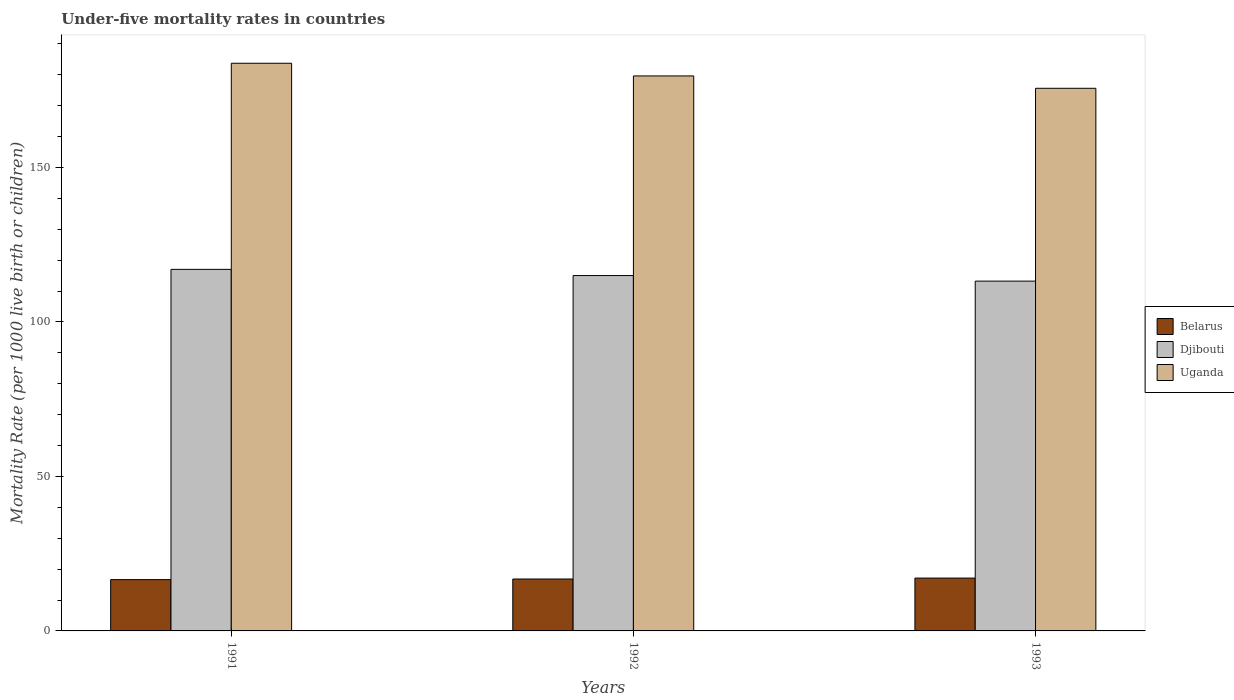How many different coloured bars are there?
Ensure brevity in your answer.  3. How many groups of bars are there?
Offer a terse response. 3. Are the number of bars per tick equal to the number of legend labels?
Your answer should be very brief. Yes. Are the number of bars on each tick of the X-axis equal?
Make the answer very short. Yes. How many bars are there on the 3rd tick from the right?
Your answer should be compact. 3. What is the label of the 2nd group of bars from the left?
Make the answer very short. 1992. In how many cases, is the number of bars for a given year not equal to the number of legend labels?
Keep it short and to the point. 0. What is the under-five mortality rate in Uganda in 1993?
Your answer should be compact. 175.6. Across all years, what is the maximum under-five mortality rate in Uganda?
Offer a terse response. 183.7. Across all years, what is the minimum under-five mortality rate in Djibouti?
Keep it short and to the point. 113.2. In which year was the under-five mortality rate in Djibouti minimum?
Offer a terse response. 1993. What is the total under-five mortality rate in Uganda in the graph?
Keep it short and to the point. 538.9. What is the difference between the under-five mortality rate in Belarus in 1991 and that in 1992?
Provide a short and direct response. -0.2. What is the difference between the under-five mortality rate in Belarus in 1992 and the under-five mortality rate in Djibouti in 1993?
Keep it short and to the point. -96.4. What is the average under-five mortality rate in Belarus per year?
Offer a very short reply. 16.83. In the year 1993, what is the difference between the under-five mortality rate in Belarus and under-five mortality rate in Uganda?
Your response must be concise. -158.5. In how many years, is the under-five mortality rate in Belarus greater than 70?
Offer a terse response. 0. What is the ratio of the under-five mortality rate in Djibouti in 1991 to that in 1993?
Offer a very short reply. 1.03. Is the difference between the under-five mortality rate in Belarus in 1991 and 1992 greater than the difference between the under-five mortality rate in Uganda in 1991 and 1992?
Keep it short and to the point. No. What is the difference between the highest and the second highest under-five mortality rate in Uganda?
Your answer should be compact. 4.1. What is the difference between the highest and the lowest under-five mortality rate in Belarus?
Your answer should be compact. 0.5. In how many years, is the under-five mortality rate in Belarus greater than the average under-five mortality rate in Belarus taken over all years?
Your response must be concise. 1. What does the 2nd bar from the left in 1991 represents?
Offer a terse response. Djibouti. What does the 1st bar from the right in 1991 represents?
Give a very brief answer. Uganda. How many bars are there?
Your answer should be very brief. 9. Are all the bars in the graph horizontal?
Offer a terse response. No. What is the difference between two consecutive major ticks on the Y-axis?
Provide a short and direct response. 50. How many legend labels are there?
Keep it short and to the point. 3. How are the legend labels stacked?
Your response must be concise. Vertical. What is the title of the graph?
Keep it short and to the point. Under-five mortality rates in countries. Does "Lithuania" appear as one of the legend labels in the graph?
Offer a very short reply. No. What is the label or title of the Y-axis?
Give a very brief answer. Mortality Rate (per 1000 live birth or children). What is the Mortality Rate (per 1000 live birth or children) in Djibouti in 1991?
Your answer should be very brief. 117. What is the Mortality Rate (per 1000 live birth or children) in Uganda in 1991?
Give a very brief answer. 183.7. What is the Mortality Rate (per 1000 live birth or children) of Belarus in 1992?
Your response must be concise. 16.8. What is the Mortality Rate (per 1000 live birth or children) in Djibouti in 1992?
Offer a terse response. 115. What is the Mortality Rate (per 1000 live birth or children) of Uganda in 1992?
Your response must be concise. 179.6. What is the Mortality Rate (per 1000 live birth or children) of Djibouti in 1993?
Provide a succinct answer. 113.2. What is the Mortality Rate (per 1000 live birth or children) of Uganda in 1993?
Provide a succinct answer. 175.6. Across all years, what is the maximum Mortality Rate (per 1000 live birth or children) in Belarus?
Ensure brevity in your answer.  17.1. Across all years, what is the maximum Mortality Rate (per 1000 live birth or children) in Djibouti?
Offer a very short reply. 117. Across all years, what is the maximum Mortality Rate (per 1000 live birth or children) of Uganda?
Your answer should be compact. 183.7. Across all years, what is the minimum Mortality Rate (per 1000 live birth or children) in Belarus?
Your answer should be compact. 16.6. Across all years, what is the minimum Mortality Rate (per 1000 live birth or children) in Djibouti?
Your answer should be compact. 113.2. Across all years, what is the minimum Mortality Rate (per 1000 live birth or children) of Uganda?
Give a very brief answer. 175.6. What is the total Mortality Rate (per 1000 live birth or children) of Belarus in the graph?
Give a very brief answer. 50.5. What is the total Mortality Rate (per 1000 live birth or children) in Djibouti in the graph?
Offer a very short reply. 345.2. What is the total Mortality Rate (per 1000 live birth or children) in Uganda in the graph?
Keep it short and to the point. 538.9. What is the difference between the Mortality Rate (per 1000 live birth or children) of Belarus in 1991 and that in 1992?
Give a very brief answer. -0.2. What is the difference between the Mortality Rate (per 1000 live birth or children) of Djibouti in 1991 and that in 1993?
Provide a succinct answer. 3.8. What is the difference between the Mortality Rate (per 1000 live birth or children) of Uganda in 1992 and that in 1993?
Make the answer very short. 4. What is the difference between the Mortality Rate (per 1000 live birth or children) in Belarus in 1991 and the Mortality Rate (per 1000 live birth or children) in Djibouti in 1992?
Offer a very short reply. -98.4. What is the difference between the Mortality Rate (per 1000 live birth or children) of Belarus in 1991 and the Mortality Rate (per 1000 live birth or children) of Uganda in 1992?
Offer a very short reply. -163. What is the difference between the Mortality Rate (per 1000 live birth or children) of Djibouti in 1991 and the Mortality Rate (per 1000 live birth or children) of Uganda in 1992?
Make the answer very short. -62.6. What is the difference between the Mortality Rate (per 1000 live birth or children) in Belarus in 1991 and the Mortality Rate (per 1000 live birth or children) in Djibouti in 1993?
Give a very brief answer. -96.6. What is the difference between the Mortality Rate (per 1000 live birth or children) of Belarus in 1991 and the Mortality Rate (per 1000 live birth or children) of Uganda in 1993?
Ensure brevity in your answer.  -159. What is the difference between the Mortality Rate (per 1000 live birth or children) of Djibouti in 1991 and the Mortality Rate (per 1000 live birth or children) of Uganda in 1993?
Provide a succinct answer. -58.6. What is the difference between the Mortality Rate (per 1000 live birth or children) in Belarus in 1992 and the Mortality Rate (per 1000 live birth or children) in Djibouti in 1993?
Make the answer very short. -96.4. What is the difference between the Mortality Rate (per 1000 live birth or children) of Belarus in 1992 and the Mortality Rate (per 1000 live birth or children) of Uganda in 1993?
Provide a short and direct response. -158.8. What is the difference between the Mortality Rate (per 1000 live birth or children) in Djibouti in 1992 and the Mortality Rate (per 1000 live birth or children) in Uganda in 1993?
Make the answer very short. -60.6. What is the average Mortality Rate (per 1000 live birth or children) in Belarus per year?
Make the answer very short. 16.83. What is the average Mortality Rate (per 1000 live birth or children) in Djibouti per year?
Your response must be concise. 115.07. What is the average Mortality Rate (per 1000 live birth or children) in Uganda per year?
Offer a very short reply. 179.63. In the year 1991, what is the difference between the Mortality Rate (per 1000 live birth or children) of Belarus and Mortality Rate (per 1000 live birth or children) of Djibouti?
Offer a very short reply. -100.4. In the year 1991, what is the difference between the Mortality Rate (per 1000 live birth or children) in Belarus and Mortality Rate (per 1000 live birth or children) in Uganda?
Offer a very short reply. -167.1. In the year 1991, what is the difference between the Mortality Rate (per 1000 live birth or children) of Djibouti and Mortality Rate (per 1000 live birth or children) of Uganda?
Keep it short and to the point. -66.7. In the year 1992, what is the difference between the Mortality Rate (per 1000 live birth or children) in Belarus and Mortality Rate (per 1000 live birth or children) in Djibouti?
Provide a short and direct response. -98.2. In the year 1992, what is the difference between the Mortality Rate (per 1000 live birth or children) in Belarus and Mortality Rate (per 1000 live birth or children) in Uganda?
Your answer should be very brief. -162.8. In the year 1992, what is the difference between the Mortality Rate (per 1000 live birth or children) of Djibouti and Mortality Rate (per 1000 live birth or children) of Uganda?
Offer a terse response. -64.6. In the year 1993, what is the difference between the Mortality Rate (per 1000 live birth or children) in Belarus and Mortality Rate (per 1000 live birth or children) in Djibouti?
Provide a short and direct response. -96.1. In the year 1993, what is the difference between the Mortality Rate (per 1000 live birth or children) of Belarus and Mortality Rate (per 1000 live birth or children) of Uganda?
Offer a very short reply. -158.5. In the year 1993, what is the difference between the Mortality Rate (per 1000 live birth or children) of Djibouti and Mortality Rate (per 1000 live birth or children) of Uganda?
Make the answer very short. -62.4. What is the ratio of the Mortality Rate (per 1000 live birth or children) of Djibouti in 1991 to that in 1992?
Make the answer very short. 1.02. What is the ratio of the Mortality Rate (per 1000 live birth or children) in Uganda in 1991 to that in 1992?
Keep it short and to the point. 1.02. What is the ratio of the Mortality Rate (per 1000 live birth or children) of Belarus in 1991 to that in 1993?
Ensure brevity in your answer.  0.97. What is the ratio of the Mortality Rate (per 1000 live birth or children) in Djibouti in 1991 to that in 1993?
Keep it short and to the point. 1.03. What is the ratio of the Mortality Rate (per 1000 live birth or children) of Uganda in 1991 to that in 1993?
Your response must be concise. 1.05. What is the ratio of the Mortality Rate (per 1000 live birth or children) in Belarus in 1992 to that in 1993?
Make the answer very short. 0.98. What is the ratio of the Mortality Rate (per 1000 live birth or children) in Djibouti in 1992 to that in 1993?
Your response must be concise. 1.02. What is the ratio of the Mortality Rate (per 1000 live birth or children) in Uganda in 1992 to that in 1993?
Keep it short and to the point. 1.02. What is the difference between the highest and the second highest Mortality Rate (per 1000 live birth or children) of Belarus?
Your answer should be compact. 0.3. What is the difference between the highest and the lowest Mortality Rate (per 1000 live birth or children) in Belarus?
Make the answer very short. 0.5. 